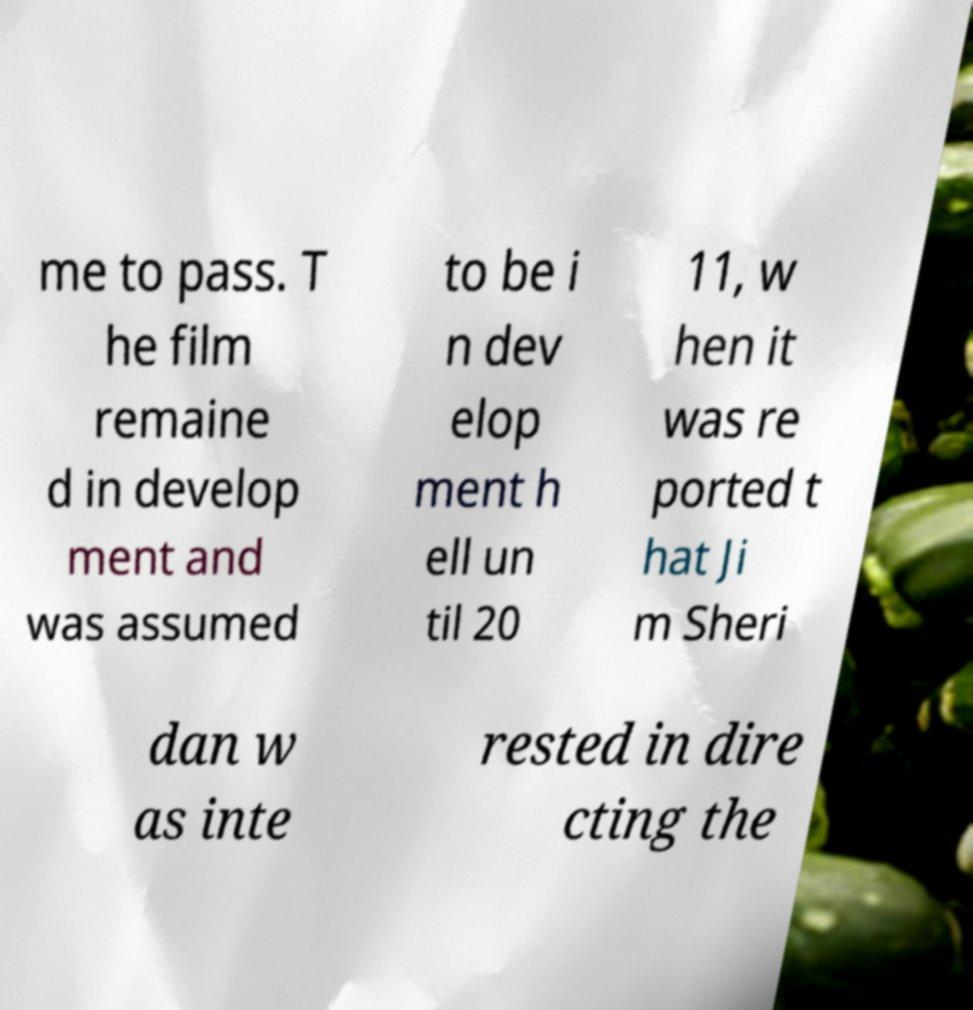What messages or text are displayed in this image? I need them in a readable, typed format. me to pass. T he film remaine d in develop ment and was assumed to be i n dev elop ment h ell un til 20 11, w hen it was re ported t hat Ji m Sheri dan w as inte rested in dire cting the 